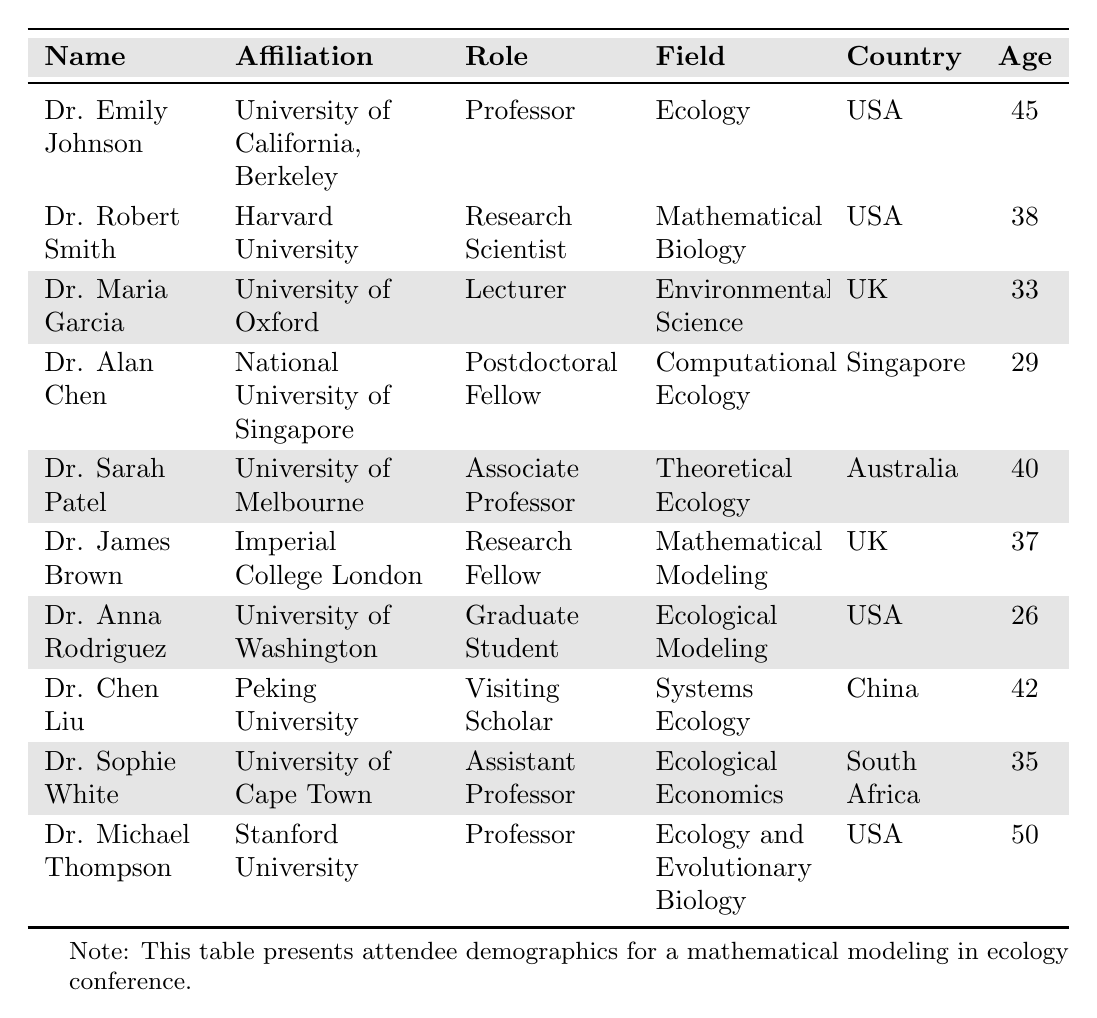What is the average age of the attendees? There are 10 attendees with ages 45, 38, 33, 29, 40, 37, 26, 42, 35, and 50. Summing these gives  45 + 38 + 33 + 29 + 40 + 37 + 26 + 42 + 35 + 50 = 405. There are 10 attendees, so the average age is 405/10 = 40.5
Answer: 40.5 How many female attendees are there? The table lists 5 female attendees: Dr. Emily Johnson, Dr. Maria Garcia, Dr. Sarah Patel, Dr. Anna Rodriguez, and Dr. Sophie White. Counting these gives a total of 5.
Answer: 5 What is the primary affiliation of the oldest attendee? The oldest attendee, Dr. Michael Thompson, is affiliated with Stanford University.
Answer: Stanford University Is there any attendee from Singapore? Yes, Dr. Alan Chen is affiliated with the National University of Singapore.
Answer: Yes What percentage of the attendees are from the USA? There are 6 attendees from the USA out of a total of 10; to find the percentage, calculate (6/10) * 100 = 60%.
Answer: 60% Which attendee is a visiting scholar? Dr. Chen Liu is identified as a visiting scholar from Peking University.
Answer: Dr. Chen Liu How many attendees have a role related to "Professor"? There are 3 attendees with the role of Professor: Dr. Emily Johnson, Dr. Michael Thompson, and Dr. Sarah Patel.
Answer: 3 What is the average age of the male attendees? The ages of male attendees are 38, 29, 37, 42, and 50. Summing these gives 38 + 29 + 37 + 42 + 50 = 196. There are 5 male attendees, so the average age is 196/5 = 39.2.
Answer: 39.2 Which country has the most attendees? The USA has 6 attendees, which is more than any other country represented in the table.
Answer: USA What is the difference in age between the youngest and oldest attendee? The youngest attendee, Dr. Anna Rodriguez, is 26 years old, and the oldest attendee, Dr. Michael Thompson, is 50 years old. The difference in age is 50 - 26 = 24 years.
Answer: 24 years 